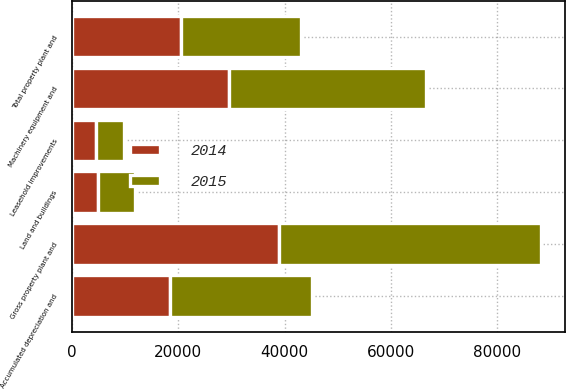<chart> <loc_0><loc_0><loc_500><loc_500><stacked_bar_chart><ecel><fcel>Land and buildings<fcel>Machinery equipment and<fcel>Leasehold improvements<fcel>Gross property plant and<fcel>Accumulated depreciation and<fcel>Total property plant and<nl><fcel>2015<fcel>6956<fcel>37038<fcel>5263<fcel>49257<fcel>26786<fcel>22471<nl><fcel>2014<fcel>4863<fcel>29639<fcel>4513<fcel>39015<fcel>18391<fcel>20624<nl></chart> 